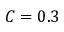<formula> <loc_0><loc_0><loc_500><loc_500>C = 0 . 3</formula> 